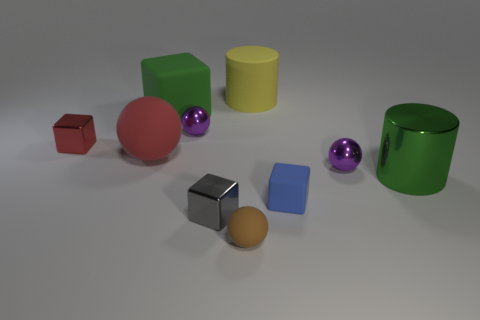Subtract all cyan cylinders. Subtract all purple spheres. How many cylinders are left? 2 Subtract all blocks. How many objects are left? 6 Add 1 tiny rubber cubes. How many tiny rubber cubes are left? 2 Add 1 small purple shiny objects. How many small purple shiny objects exist? 3 Subtract 1 red spheres. How many objects are left? 9 Subtract all blue rubber things. Subtract all tiny purple matte cylinders. How many objects are left? 9 